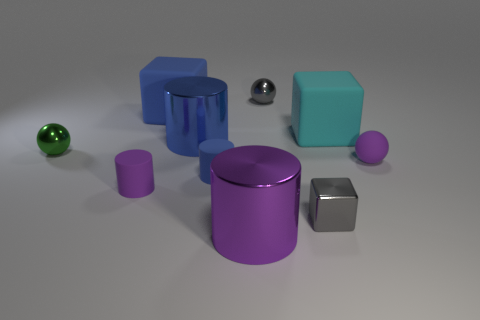There is a small rubber ball; is its color the same as the big shiny cylinder that is in front of the green object?
Your response must be concise. Yes. What is the material of the big thing right of the gray thing that is in front of the gray metallic object behind the green sphere?
Your answer should be compact. Rubber. Do the large cyan object and the big matte object on the left side of the blue matte cylinder have the same shape?
Your response must be concise. Yes. What number of other small shiny objects are the same shape as the cyan object?
Offer a very short reply. 1. The big purple metal object has what shape?
Make the answer very short. Cylinder. There is a gray object that is behind the small matte cylinder that is right of the blue metallic object; what size is it?
Your response must be concise. Small. How many objects are either small purple balls or small matte objects?
Make the answer very short. 3. Is the purple shiny thing the same shape as the small blue object?
Provide a short and direct response. Yes. Are there any red balls that have the same material as the tiny gray sphere?
Your answer should be very brief. No. Are there any metallic objects that are behind the small ball that is in front of the green metallic thing?
Give a very brief answer. Yes. 